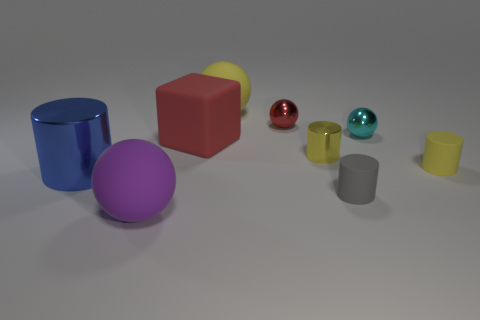Subtract 1 balls. How many balls are left? 3 Subtract all purple cylinders. Subtract all purple spheres. How many cylinders are left? 4 Add 1 tiny cyan metallic things. How many objects exist? 10 Subtract all cylinders. How many objects are left? 5 Add 2 small red shiny spheres. How many small red shiny spheres exist? 3 Subtract 0 brown cylinders. How many objects are left? 9 Subtract all small brown metal blocks. Subtract all large purple rubber balls. How many objects are left? 8 Add 4 tiny shiny balls. How many tiny shiny balls are left? 6 